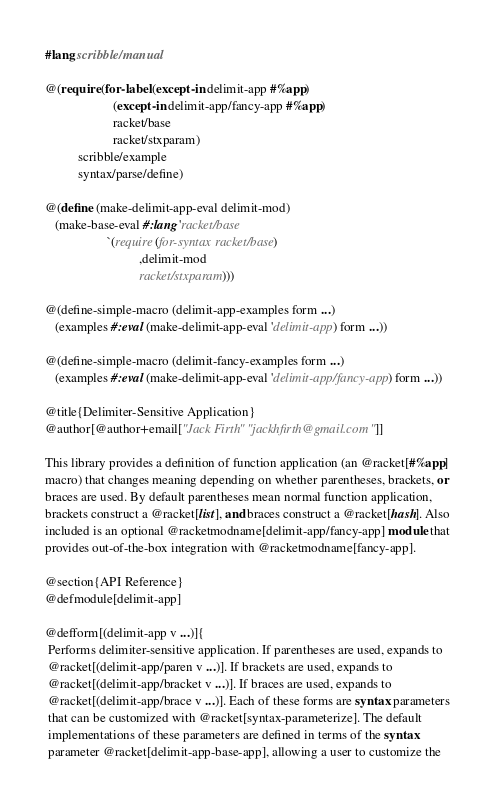Convert code to text. <code><loc_0><loc_0><loc_500><loc_500><_Racket_>#lang scribble/manual

@(require (for-label (except-in delimit-app #%app)
                     (except-in delimit-app/fancy-app #%app)
                     racket/base
                     racket/stxparam)
          scribble/example
          syntax/parse/define)

@(define (make-delimit-app-eval delimit-mod)
   (make-base-eval #:lang 'racket/base
                   `(require (for-syntax racket/base)
                             ,delimit-mod
                             racket/stxparam)))

@(define-simple-macro (delimit-app-examples form ...)
   (examples #:eval (make-delimit-app-eval 'delimit-app) form ...))

@(define-simple-macro (delimit-fancy-examples form ...)
   (examples #:eval (make-delimit-app-eval 'delimit-app/fancy-app) form ...))

@title{Delimiter-Sensitive Application}
@author[@author+email["Jack Firth" "jackhfirth@gmail.com"]]

This library provides a definition of function application (an @racket[#%app]
macro) that changes meaning depending on whether parentheses, brackets, or
braces are used. By default parentheses mean normal function application,
brackets construct a @racket[list], and braces construct a @racket[hash]. Also
included is an optional @racketmodname[delimit-app/fancy-app] module that
provides out-of-the-box integration with @racketmodname[fancy-app].

@section{API Reference}
@defmodule[delimit-app]

@defform[(delimit-app v ...)]{
 Performs delimiter-sensitive application. If parentheses are used, expands to
 @racket[(delimit-app/paren v ...)]. If brackets are used, expands to
 @racket[(delimit-app/bracket v ...)]. If braces are used, expands to
 @racket[(delimit-app/brace v ...)]. Each of these forms are syntax parameters
 that can be customized with @racket[syntax-parameterize]. The default
 implementations of these parameters are defined in terms of the syntax
 parameter @racket[delimit-app-base-app], allowing a user to customize the</code> 